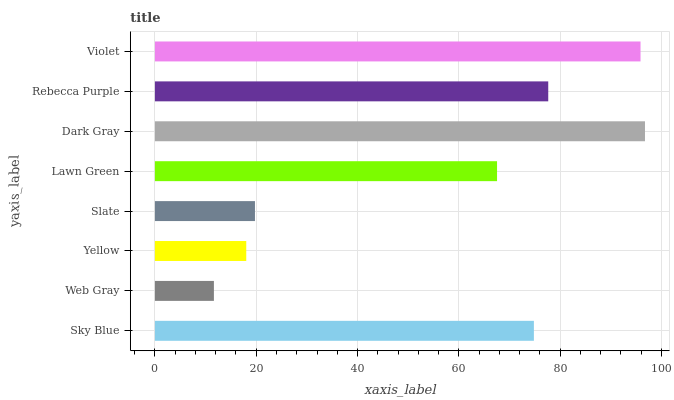Is Web Gray the minimum?
Answer yes or no. Yes. Is Dark Gray the maximum?
Answer yes or no. Yes. Is Yellow the minimum?
Answer yes or no. No. Is Yellow the maximum?
Answer yes or no. No. Is Yellow greater than Web Gray?
Answer yes or no. Yes. Is Web Gray less than Yellow?
Answer yes or no. Yes. Is Web Gray greater than Yellow?
Answer yes or no. No. Is Yellow less than Web Gray?
Answer yes or no. No. Is Sky Blue the high median?
Answer yes or no. Yes. Is Lawn Green the low median?
Answer yes or no. Yes. Is Violet the high median?
Answer yes or no. No. Is Yellow the low median?
Answer yes or no. No. 